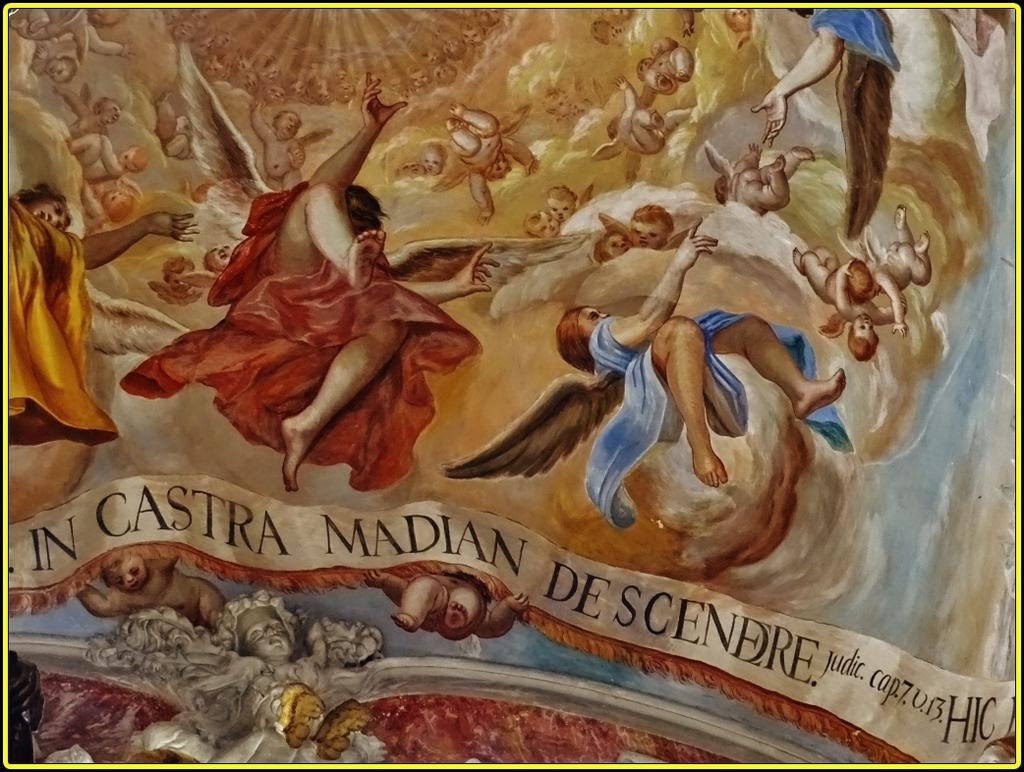<image>
Provide a brief description of the given image. A painting of angels and the words In Castra Madian De Scendre at the bottom. 